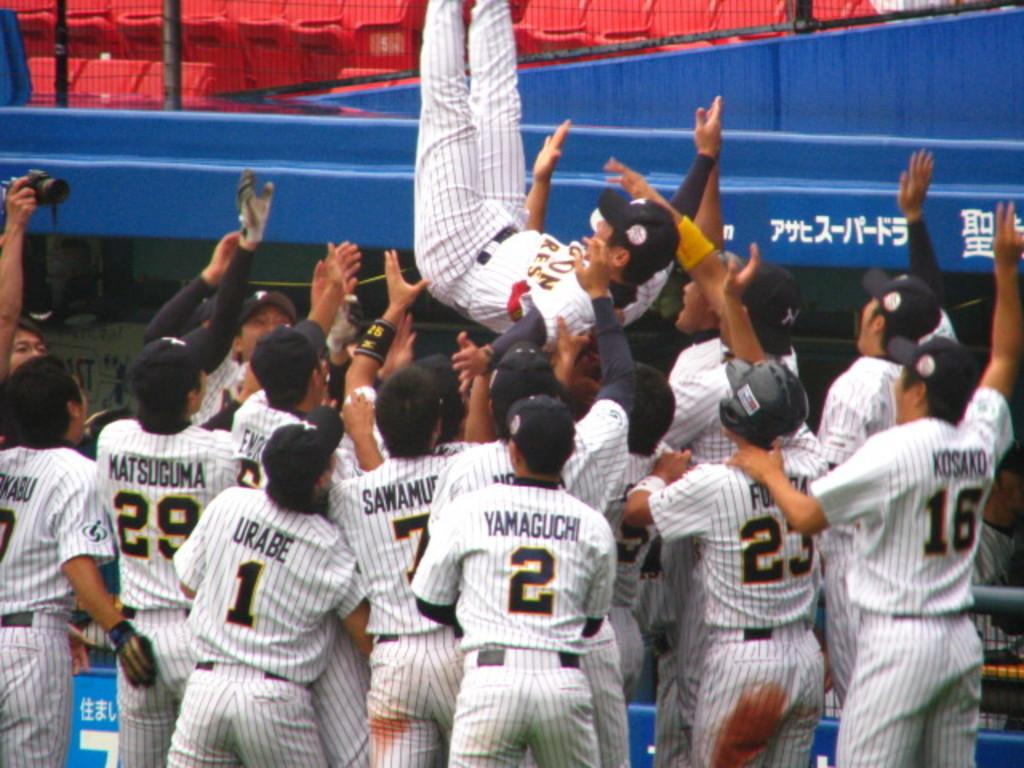<image>
Provide a brief description of the given image. A baseball player jumps into the rest of the baseball team with Yamaguchi in the back watching. 